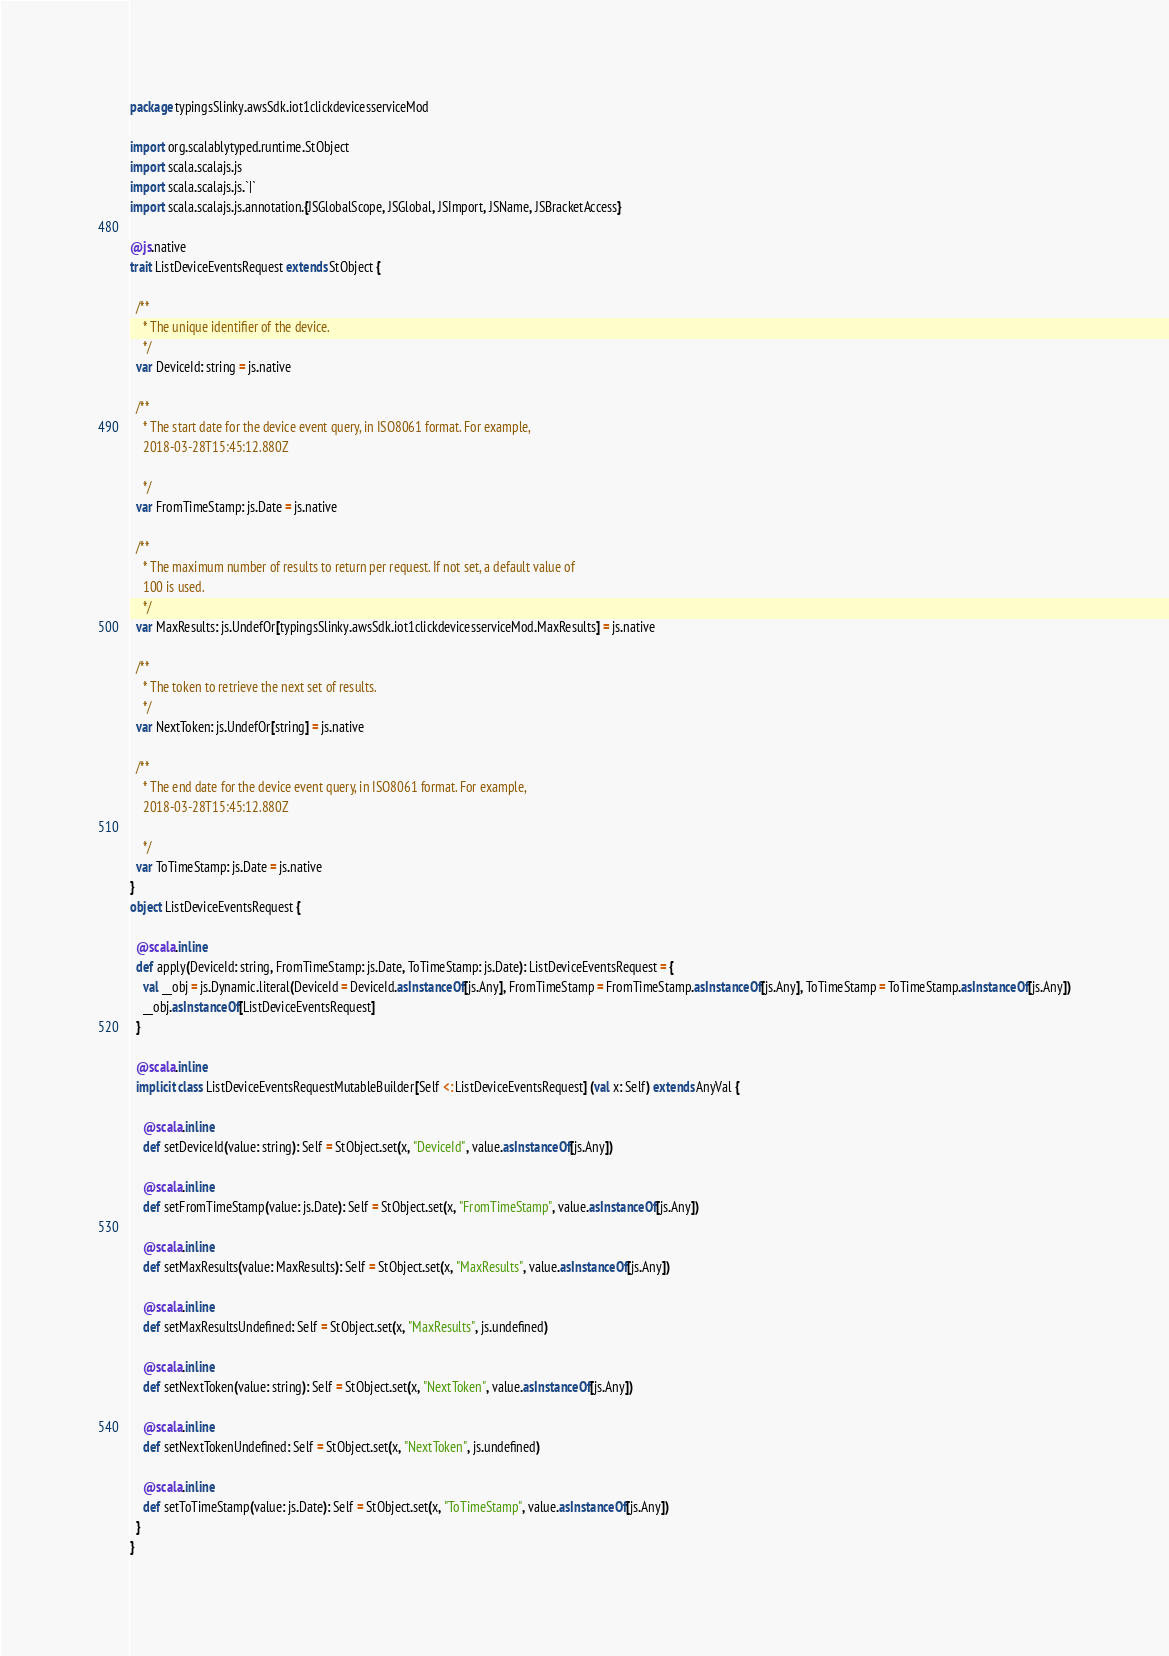Convert code to text. <code><loc_0><loc_0><loc_500><loc_500><_Scala_>package typingsSlinky.awsSdk.iot1clickdevicesserviceMod

import org.scalablytyped.runtime.StObject
import scala.scalajs.js
import scala.scalajs.js.`|`
import scala.scalajs.js.annotation.{JSGlobalScope, JSGlobal, JSImport, JSName, JSBracketAccess}

@js.native
trait ListDeviceEventsRequest extends StObject {
  
  /**
    * The unique identifier of the device.
    */
  var DeviceId: string = js.native
  
  /**
    * The start date for the device event query, in ISO8061 format. For example,
    2018-03-28T15:45:12.880Z
    
    */
  var FromTimeStamp: js.Date = js.native
  
  /**
    * The maximum number of results to return per request. If not set, a default value of
    100 is used.
    */
  var MaxResults: js.UndefOr[typingsSlinky.awsSdk.iot1clickdevicesserviceMod.MaxResults] = js.native
  
  /**
    * The token to retrieve the next set of results.
    */
  var NextToken: js.UndefOr[string] = js.native
  
  /**
    * The end date for the device event query, in ISO8061 format. For example,
    2018-03-28T15:45:12.880Z
    
    */
  var ToTimeStamp: js.Date = js.native
}
object ListDeviceEventsRequest {
  
  @scala.inline
  def apply(DeviceId: string, FromTimeStamp: js.Date, ToTimeStamp: js.Date): ListDeviceEventsRequest = {
    val __obj = js.Dynamic.literal(DeviceId = DeviceId.asInstanceOf[js.Any], FromTimeStamp = FromTimeStamp.asInstanceOf[js.Any], ToTimeStamp = ToTimeStamp.asInstanceOf[js.Any])
    __obj.asInstanceOf[ListDeviceEventsRequest]
  }
  
  @scala.inline
  implicit class ListDeviceEventsRequestMutableBuilder[Self <: ListDeviceEventsRequest] (val x: Self) extends AnyVal {
    
    @scala.inline
    def setDeviceId(value: string): Self = StObject.set(x, "DeviceId", value.asInstanceOf[js.Any])
    
    @scala.inline
    def setFromTimeStamp(value: js.Date): Self = StObject.set(x, "FromTimeStamp", value.asInstanceOf[js.Any])
    
    @scala.inline
    def setMaxResults(value: MaxResults): Self = StObject.set(x, "MaxResults", value.asInstanceOf[js.Any])
    
    @scala.inline
    def setMaxResultsUndefined: Self = StObject.set(x, "MaxResults", js.undefined)
    
    @scala.inline
    def setNextToken(value: string): Self = StObject.set(x, "NextToken", value.asInstanceOf[js.Any])
    
    @scala.inline
    def setNextTokenUndefined: Self = StObject.set(x, "NextToken", js.undefined)
    
    @scala.inline
    def setToTimeStamp(value: js.Date): Self = StObject.set(x, "ToTimeStamp", value.asInstanceOf[js.Any])
  }
}
</code> 